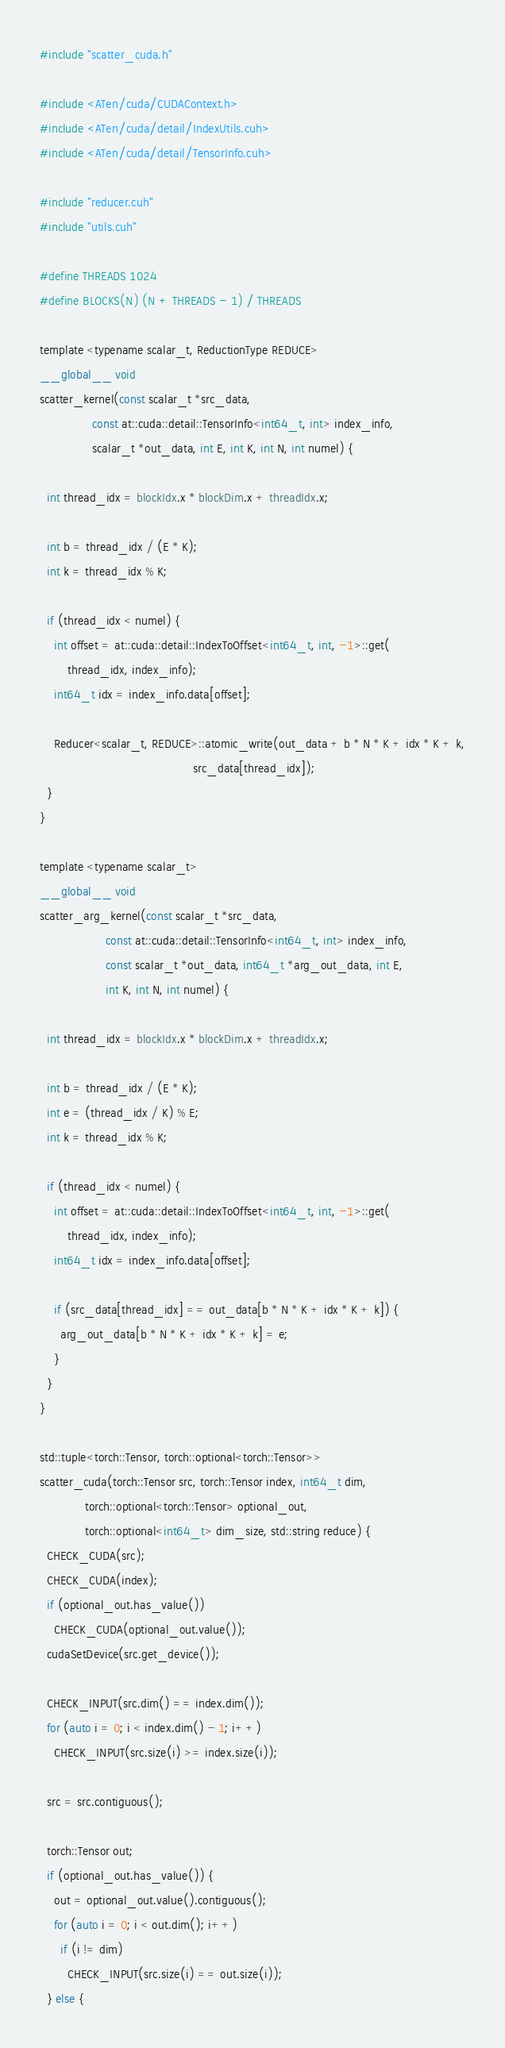Convert code to text. <code><loc_0><loc_0><loc_500><loc_500><_Cuda_>#include "scatter_cuda.h"

#include <ATen/cuda/CUDAContext.h>
#include <ATen/cuda/detail/IndexUtils.cuh>
#include <ATen/cuda/detail/TensorInfo.cuh>

#include "reducer.cuh"
#include "utils.cuh"

#define THREADS 1024
#define BLOCKS(N) (N + THREADS - 1) / THREADS

template <typename scalar_t, ReductionType REDUCE>
__global__ void
scatter_kernel(const scalar_t *src_data,
               const at::cuda::detail::TensorInfo<int64_t, int> index_info,
               scalar_t *out_data, int E, int K, int N, int numel) {

  int thread_idx = blockIdx.x * blockDim.x + threadIdx.x;

  int b = thread_idx / (E * K);
  int k = thread_idx % K;

  if (thread_idx < numel) {
    int offset = at::cuda::detail::IndexToOffset<int64_t, int, -1>::get(
        thread_idx, index_info);
    int64_t idx = index_info.data[offset];

    Reducer<scalar_t, REDUCE>::atomic_write(out_data + b * N * K + idx * K + k,
                                            src_data[thread_idx]);
  }
}

template <typename scalar_t>
__global__ void
scatter_arg_kernel(const scalar_t *src_data,
                   const at::cuda::detail::TensorInfo<int64_t, int> index_info,
                   const scalar_t *out_data, int64_t *arg_out_data, int E,
                   int K, int N, int numel) {

  int thread_idx = blockIdx.x * blockDim.x + threadIdx.x;

  int b = thread_idx / (E * K);
  int e = (thread_idx / K) % E;
  int k = thread_idx % K;

  if (thread_idx < numel) {
    int offset = at::cuda::detail::IndexToOffset<int64_t, int, -1>::get(
        thread_idx, index_info);
    int64_t idx = index_info.data[offset];

    if (src_data[thread_idx] == out_data[b * N * K + idx * K + k]) {
      arg_out_data[b * N * K + idx * K + k] = e;
    }
  }
}

std::tuple<torch::Tensor, torch::optional<torch::Tensor>>
scatter_cuda(torch::Tensor src, torch::Tensor index, int64_t dim,
             torch::optional<torch::Tensor> optional_out,
             torch::optional<int64_t> dim_size, std::string reduce) {
  CHECK_CUDA(src);
  CHECK_CUDA(index);
  if (optional_out.has_value())
    CHECK_CUDA(optional_out.value());
  cudaSetDevice(src.get_device());

  CHECK_INPUT(src.dim() == index.dim());
  for (auto i = 0; i < index.dim() - 1; i++)
    CHECK_INPUT(src.size(i) >= index.size(i));

  src = src.contiguous();

  torch::Tensor out;
  if (optional_out.has_value()) {
    out = optional_out.value().contiguous();
    for (auto i = 0; i < out.dim(); i++)
      if (i != dim)
        CHECK_INPUT(src.size(i) == out.size(i));
  } else {</code> 